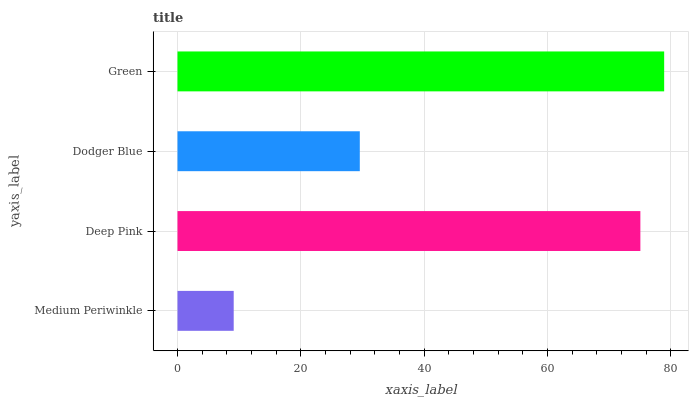Is Medium Periwinkle the minimum?
Answer yes or no. Yes. Is Green the maximum?
Answer yes or no. Yes. Is Deep Pink the minimum?
Answer yes or no. No. Is Deep Pink the maximum?
Answer yes or no. No. Is Deep Pink greater than Medium Periwinkle?
Answer yes or no. Yes. Is Medium Periwinkle less than Deep Pink?
Answer yes or no. Yes. Is Medium Periwinkle greater than Deep Pink?
Answer yes or no. No. Is Deep Pink less than Medium Periwinkle?
Answer yes or no. No. Is Deep Pink the high median?
Answer yes or no. Yes. Is Dodger Blue the low median?
Answer yes or no. Yes. Is Dodger Blue the high median?
Answer yes or no. No. Is Medium Periwinkle the low median?
Answer yes or no. No. 